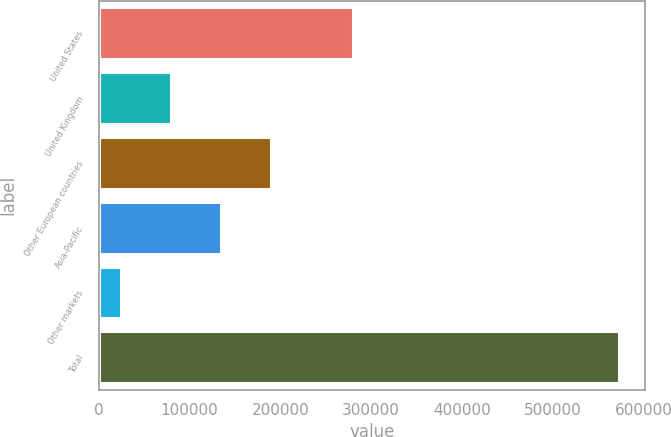Convert chart to OTSL. <chart><loc_0><loc_0><loc_500><loc_500><bar_chart><fcel>United States<fcel>United Kingdom<fcel>Other European countries<fcel>Asia-Pacific<fcel>Other markets<fcel>Total<nl><fcel>280064<fcel>79868.4<fcel>189503<fcel>134686<fcel>25051<fcel>573225<nl></chart> 